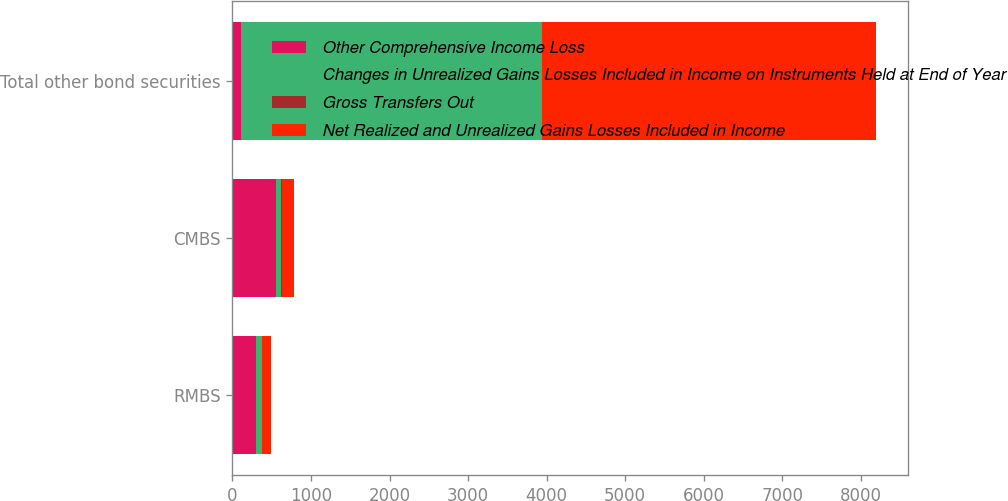<chart> <loc_0><loc_0><loc_500><loc_500><stacked_bar_chart><ecel><fcel>RMBS<fcel>CMBS<fcel>Total other bond securities<nl><fcel>Other Comprehensive Income Loss<fcel>303<fcel>554<fcel>109<nl><fcel>Changes in Unrealized Gains Losses Included in Income on Instruments Held at End of Year<fcel>76<fcel>70<fcel>3829<nl><fcel>Gross Transfers Out<fcel>2<fcel>2<fcel>7<nl><fcel>Net Realized and Unrealized Gains Losses Included in Income<fcel>109<fcel>159<fcel>4243<nl></chart> 